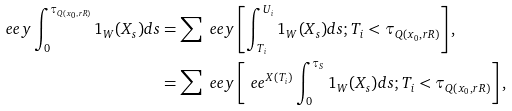Convert formula to latex. <formula><loc_0><loc_0><loc_500><loc_500>\ e e y \int _ { 0 } ^ { \tau _ { Q ( x _ { 0 } , r R ) } } 1 _ { W } ( X _ { s } ) d s & = \sum \ e e y \left [ \int _ { T _ { i } } ^ { U _ { i } } 1 _ { W } ( X _ { s } ) d s ; T _ { i } < \tau _ { Q ( x _ { 0 } , r R ) } \right ] , \\ & = \sum \ e e y \left [ \ e e ^ { X ( T _ { i } ) } \int _ { 0 } ^ { \tau _ { S } } 1 _ { W } ( X _ { s } ) d s ; T _ { i } < \tau _ { Q ( x _ { 0 } , r R ) } \right ] ,</formula> 